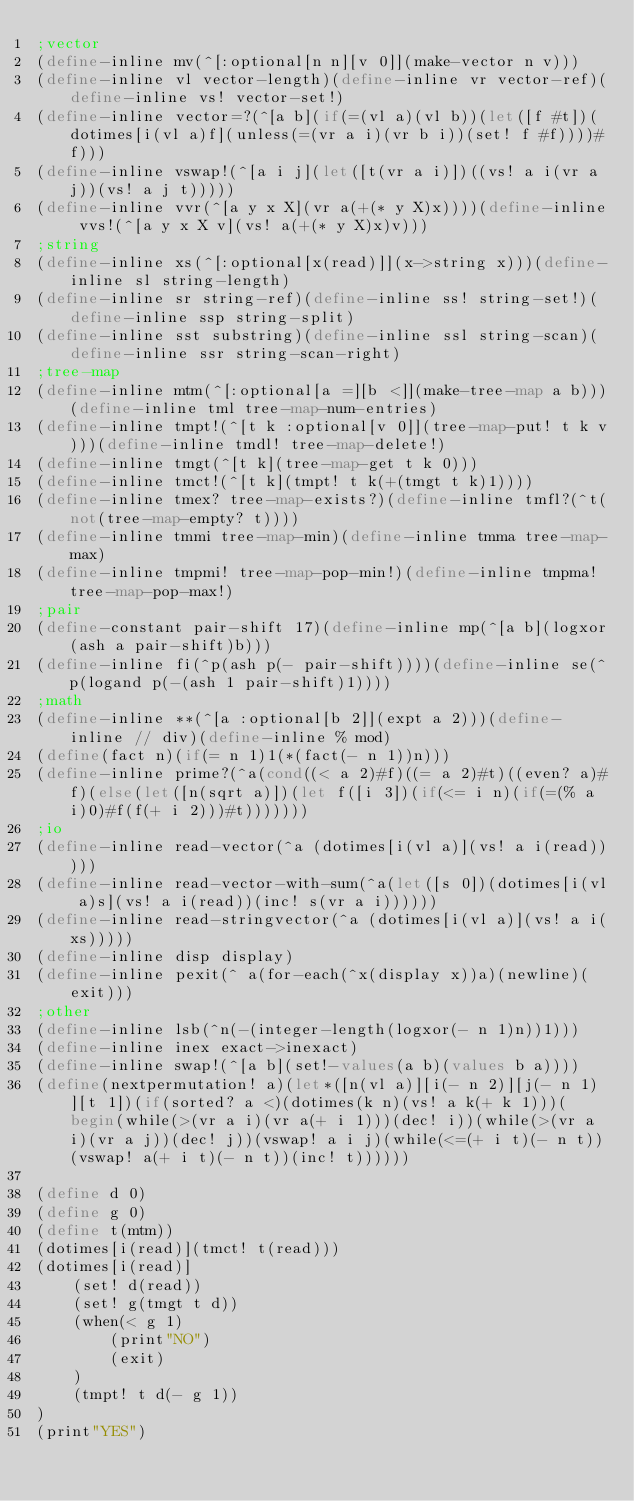Convert code to text. <code><loc_0><loc_0><loc_500><loc_500><_Scheme_>;vector
(define-inline mv(^[:optional[n n][v 0]](make-vector n v)))
(define-inline vl vector-length)(define-inline vr vector-ref)(define-inline vs! vector-set!)
(define-inline vector=?(^[a b](if(=(vl a)(vl b))(let([f #t])(dotimes[i(vl a)f](unless(=(vr a i)(vr b i))(set! f #f))))#f)))
(define-inline vswap!(^[a i j](let([t(vr a i)])((vs! a i(vr a j))(vs! a j t)))))
(define-inline vvr(^[a y x X](vr a(+(* y X)x))))(define-inline vvs!(^[a y x X v](vs! a(+(* y X)x)v)))
;string
(define-inline xs(^[:optional[x(read)]](x->string x)))(define-inline sl string-length)
(define-inline sr string-ref)(define-inline ss! string-set!)(define-inline ssp string-split)
(define-inline sst substring)(define-inline ssl string-scan)(define-inline ssr string-scan-right)
;tree-map
(define-inline mtm(^[:optional[a =][b <]](make-tree-map a b)))(define-inline tml tree-map-num-entries)
(define-inline tmpt!(^[t k :optional[v 0]](tree-map-put! t k v)))(define-inline tmdl! tree-map-delete!)
(define-inline tmgt(^[t k](tree-map-get t k 0)))
(define-inline tmct!(^[t k](tmpt! t k(+(tmgt t k)1))))
(define-inline tmex? tree-map-exists?)(define-inline tmfl?(^t(not(tree-map-empty? t))))
(define-inline tmmi tree-map-min)(define-inline tmma tree-map-max)
(define-inline tmpmi! tree-map-pop-min!)(define-inline tmpma! tree-map-pop-max!)
;pair
(define-constant pair-shift 17)(define-inline mp(^[a b](logxor(ash a pair-shift)b)))
(define-inline fi(^p(ash p(- pair-shift))))(define-inline se(^p(logand p(-(ash 1 pair-shift)1))))
;math
(define-inline **(^[a :optional[b 2]](expt a 2)))(define-inline // div)(define-inline % mod)
(define(fact n)(if(= n 1)1(*(fact(- n 1))n)))
(define-inline prime?(^a(cond((< a 2)#f)((= a 2)#t)((even? a)#f)(else(let([n(sqrt a)])(let f([i 3])(if(<= i n)(if(=(% a i)0)#f(f(+ i 2)))#t)))))))
;io
(define-inline read-vector(^a (dotimes[i(vl a)](vs! a i(read)))))
(define-inline read-vector-with-sum(^a(let([s 0])(dotimes[i(vl a)s](vs! a i(read))(inc! s(vr a i))))))
(define-inline read-stringvector(^a (dotimes[i(vl a)](vs! a i(xs)))))
(define-inline disp display)
(define-inline pexit(^ a(for-each(^x(display x))a)(newline)(exit)))
;other
(define-inline lsb(^n(-(integer-length(logxor(- n 1)n))1)))
(define-inline inex exact->inexact)
(define-inline swap!(^[a b](set!-values(a b)(values b a))))
(define(nextpermutation! a)(let*([n(vl a)][i(- n 2)][j(- n 1)][t 1])(if(sorted? a <)(dotimes(k n)(vs! a k(+ k 1)))(begin(while(>(vr a i)(vr a(+ i 1)))(dec! i))(while(>(vr a i)(vr a j))(dec! j))(vswap! a i j)(while(<=(+ i t)(- n t))(vswap! a(+ i t)(- n t))(inc! t))))))

(define d 0)
(define g 0)
(define t(mtm))
(dotimes[i(read)](tmct! t(read)))
(dotimes[i(read)]
	(set! d(read))
	(set! g(tmgt t d))
	(when(< g 1)
		(print"NO")
		(exit)
	)
	(tmpt! t d(- g 1))
)
(print"YES")</code> 